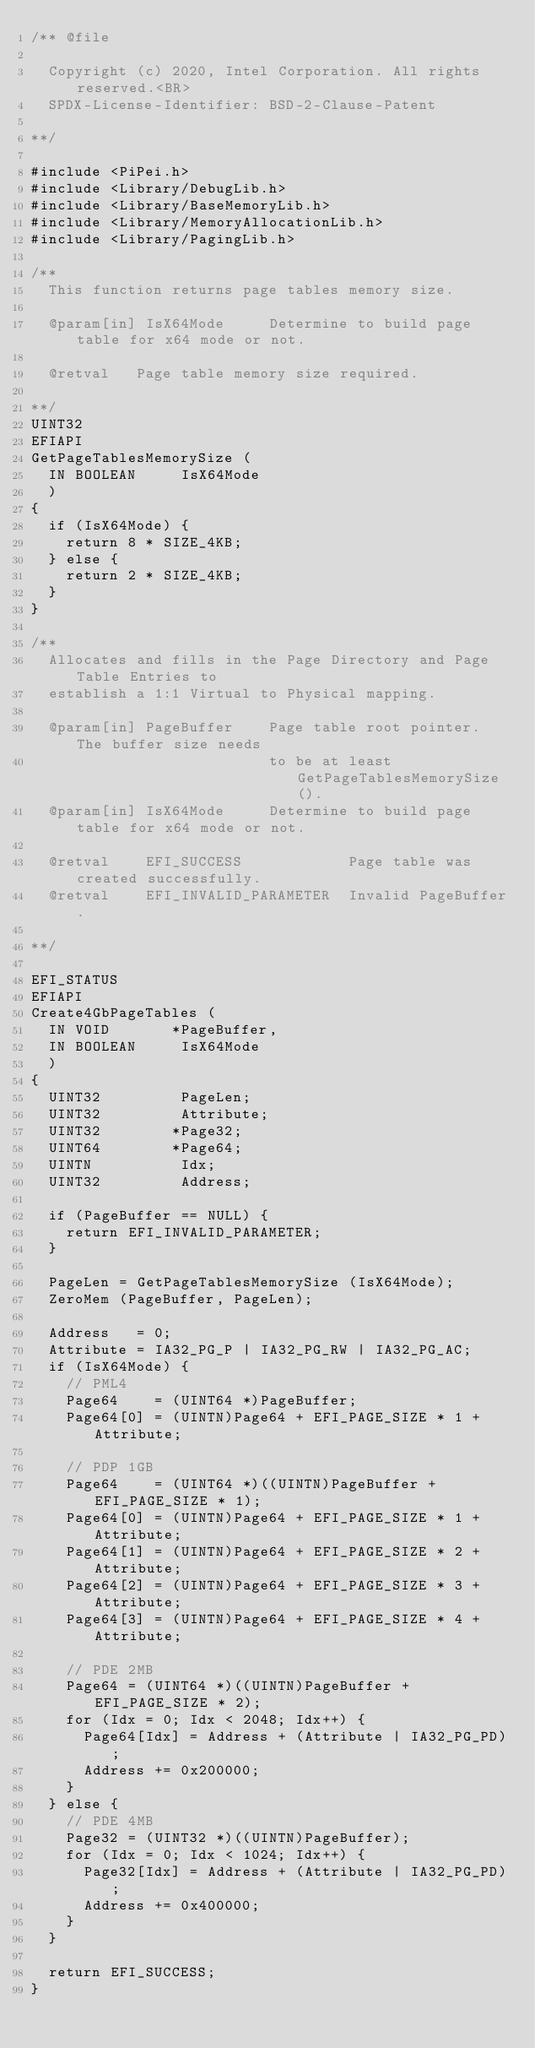Convert code to text. <code><loc_0><loc_0><loc_500><loc_500><_C_>/** @file

  Copyright (c) 2020, Intel Corporation. All rights reserved.<BR>
  SPDX-License-Identifier: BSD-2-Clause-Patent

**/

#include <PiPei.h>
#include <Library/DebugLib.h>
#include <Library/BaseMemoryLib.h>
#include <Library/MemoryAllocationLib.h>
#include <Library/PagingLib.h>

/**
  This function returns page tables memory size.

  @param[in] IsX64Mode     Determine to build page table for x64 mode or not.

  @retval   Page table memory size required.

**/
UINT32
EFIAPI
GetPageTablesMemorySize (
  IN BOOLEAN     IsX64Mode
  )
{
  if (IsX64Mode) {
    return 8 * SIZE_4KB;
  } else {
    return 2 * SIZE_4KB;
  }
}

/**
  Allocates and fills in the Page Directory and Page Table Entries to
  establish a 1:1 Virtual to Physical mapping.

  @param[in] PageBuffer    Page table root pointer. The buffer size needs
                           to be at least GetPageTablesMemorySize().
  @param[in] IsX64Mode     Determine to build page table for x64 mode or not.

  @retval    EFI_SUCCESS            Page table was created successfully.
  @retval    EFI_INVALID_PARAMETER  Invalid PageBuffer.

**/

EFI_STATUS
EFIAPI
Create4GbPageTables (
  IN VOID       *PageBuffer,
  IN BOOLEAN     IsX64Mode
  )
{
  UINT32         PageLen;
  UINT32         Attribute;
  UINT32        *Page32;
  UINT64        *Page64;
  UINTN          Idx;
  UINT32         Address;

  if (PageBuffer == NULL) {
    return EFI_INVALID_PARAMETER;
  }

  PageLen = GetPageTablesMemorySize (IsX64Mode);
  ZeroMem (PageBuffer, PageLen);

  Address   = 0;
  Attribute = IA32_PG_P | IA32_PG_RW | IA32_PG_AC;
  if (IsX64Mode) {
    // PML4
    Page64    = (UINT64 *)PageBuffer;
    Page64[0] = (UINTN)Page64 + EFI_PAGE_SIZE * 1 + Attribute;

    // PDP 1GB
    Page64    = (UINT64 *)((UINTN)PageBuffer + EFI_PAGE_SIZE * 1);
    Page64[0] = (UINTN)Page64 + EFI_PAGE_SIZE * 1 + Attribute;
    Page64[1] = (UINTN)Page64 + EFI_PAGE_SIZE * 2 + Attribute;
    Page64[2] = (UINTN)Page64 + EFI_PAGE_SIZE * 3 + Attribute;
    Page64[3] = (UINTN)Page64 + EFI_PAGE_SIZE * 4 + Attribute;

    // PDE 2MB
    Page64 = (UINT64 *)((UINTN)PageBuffer + EFI_PAGE_SIZE * 2);
    for (Idx = 0; Idx < 2048; Idx++) {
      Page64[Idx] = Address + (Attribute | IA32_PG_PD);
      Address += 0x200000;
    }
  } else {
    // PDE 4MB
    Page32 = (UINT32 *)((UINTN)PageBuffer);
    for (Idx = 0; Idx < 1024; Idx++) {
      Page32[Idx] = Address + (Attribute | IA32_PG_PD);
      Address += 0x400000;
    }
  }

  return EFI_SUCCESS;
}
</code> 